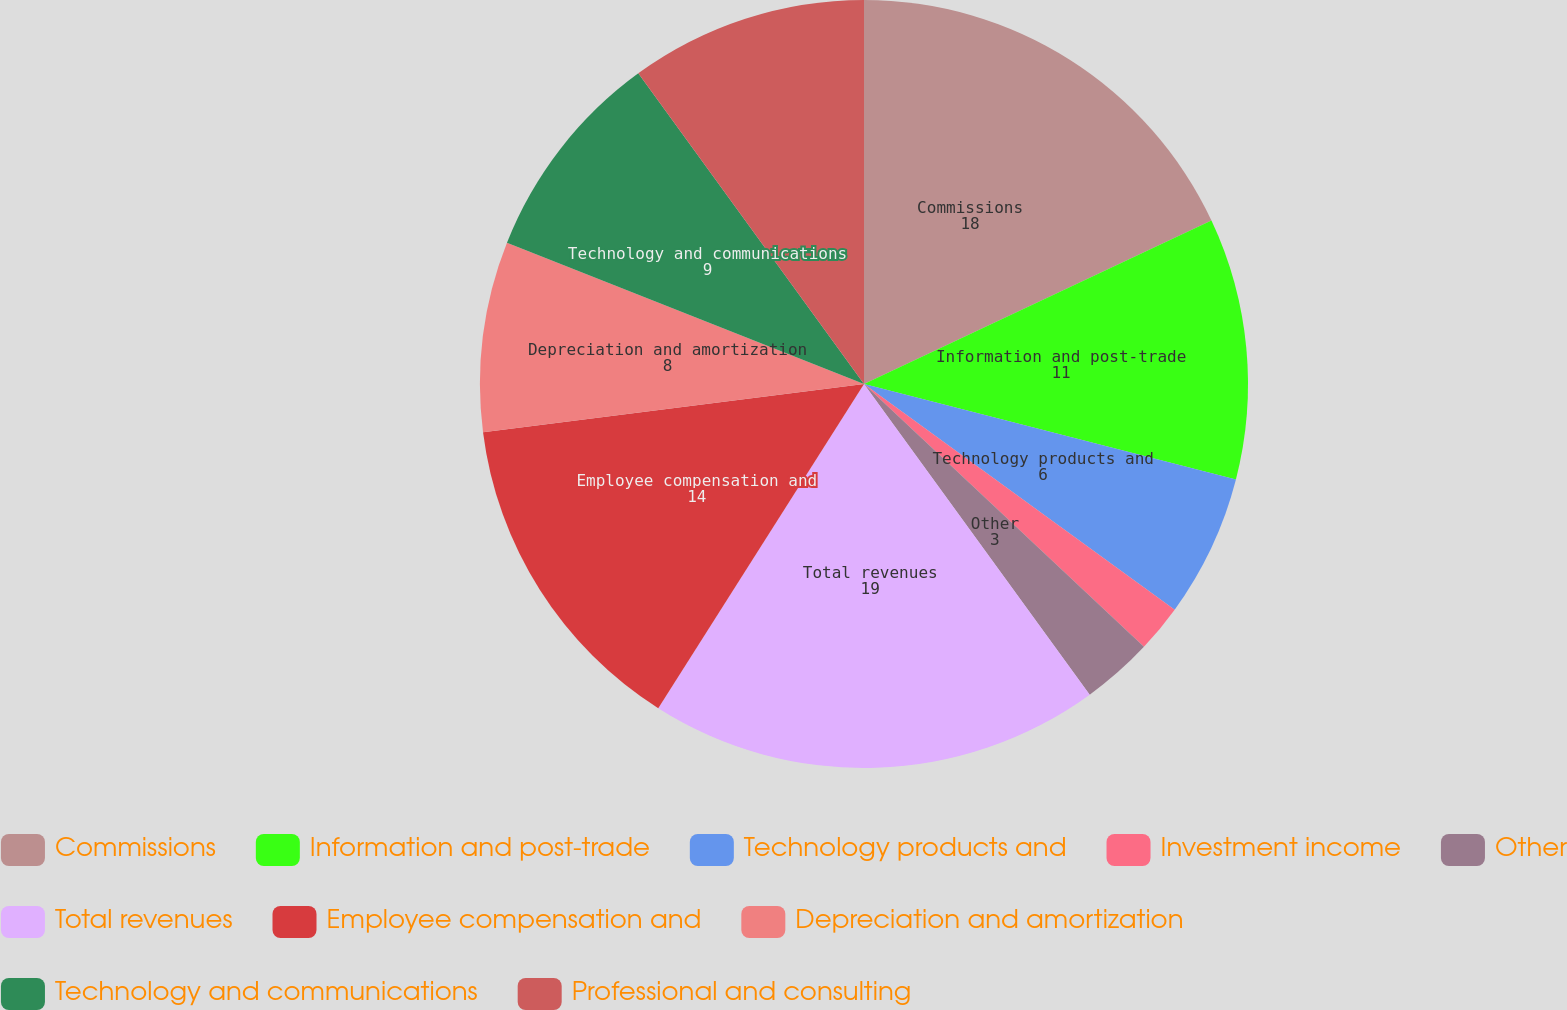Convert chart to OTSL. <chart><loc_0><loc_0><loc_500><loc_500><pie_chart><fcel>Commissions<fcel>Information and post-trade<fcel>Technology products and<fcel>Investment income<fcel>Other<fcel>Total revenues<fcel>Employee compensation and<fcel>Depreciation and amortization<fcel>Technology and communications<fcel>Professional and consulting<nl><fcel>18.0%<fcel>11.0%<fcel>6.0%<fcel>2.0%<fcel>3.0%<fcel>19.0%<fcel>14.0%<fcel>8.0%<fcel>9.0%<fcel>10.0%<nl></chart> 